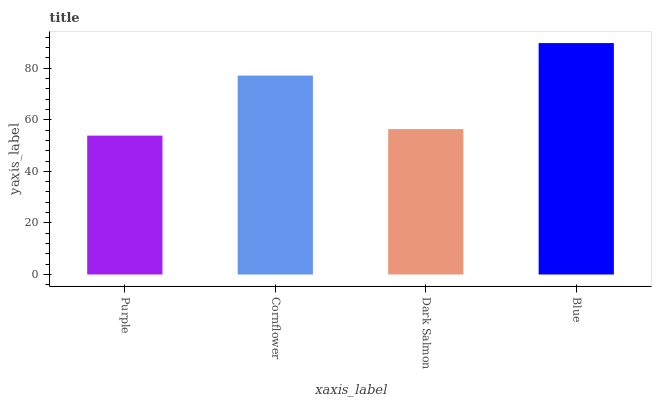Is Purple the minimum?
Answer yes or no. Yes. Is Blue the maximum?
Answer yes or no. Yes. Is Cornflower the minimum?
Answer yes or no. No. Is Cornflower the maximum?
Answer yes or no. No. Is Cornflower greater than Purple?
Answer yes or no. Yes. Is Purple less than Cornflower?
Answer yes or no. Yes. Is Purple greater than Cornflower?
Answer yes or no. No. Is Cornflower less than Purple?
Answer yes or no. No. Is Cornflower the high median?
Answer yes or no. Yes. Is Dark Salmon the low median?
Answer yes or no. Yes. Is Purple the high median?
Answer yes or no. No. Is Purple the low median?
Answer yes or no. No. 